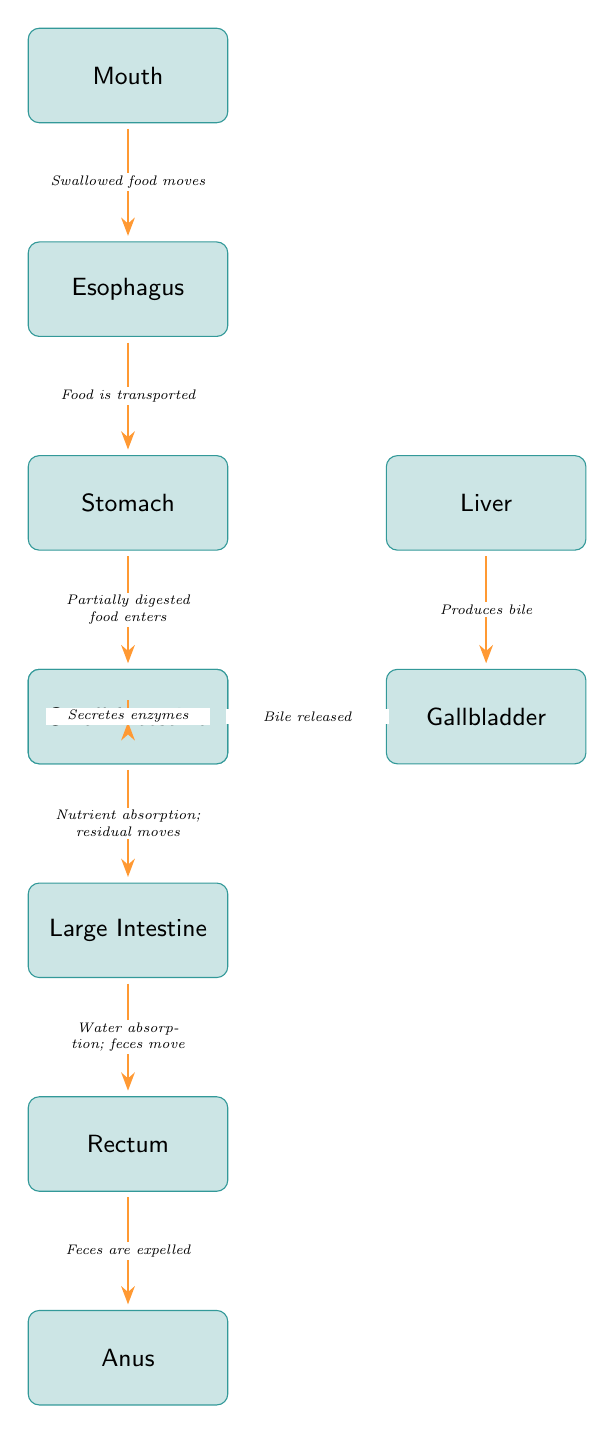What is the first organ where food enters the digestive system? The diagram indicates that food first enters the "Mouth," which is clearly labeled at the top of the flowchart.
Answer: Mouth How many organs are involved in the digestive process according to the diagram? By counting the labeled organs in the diagram, we find 10 organs: Mouth, Esophagus, Stomach, Liver, Gallbladder, Pancreas, Small Intestine, Large Intestine, Rectum, and Anus.
Answer: 10 What process occurs after food moves from the Stomach? The diagram shows that food enters the "Small Intestine" after it leaves the "Stomach," indicating that this is the next step in the process.
Answer: Small Intestine Which organ produces bile? The diagram specifically states that the "Liver" is responsible for producing bile, as indicated in the flow between the Liver and Gallbladder.
Answer: Liver What happens to the residual food after nutrient absorption in the Small Intestine? The diagram indicates that after nutrient absorption in the "Small Intestine," the residual food moves into the "Large Intestine," explaining the progression of digestion.
Answer: Large Intestine How does bile reach the Small Intestine? The flowchart shows that the "Gallbladder" releases bile into the "Small Intestine," establishing the connection between the two organs involved in digestion.
Answer: Bile released How is food transported from the Esophagus to the Stomach? The diagram states that food is transported directly from the "Esophagus" to the "Stomach," represented by a directed arrow indicating this process.
Answer: Food is transported What is the final outcome of the digestive process as indicated in the diagram? The diagram concludes with the "Anus," which is the organ responsible for expelling feces, summarizing the final outcome of the digestive process showcased in the flowchart.
Answer: Anus What role does the Pancreas play in digestion according to the diagram? The diagram notes that the "Pancreas" secretes enzymes into the "Small Intestine," highlighting its function in the digestive process.
Answer: Secretes enzymes 